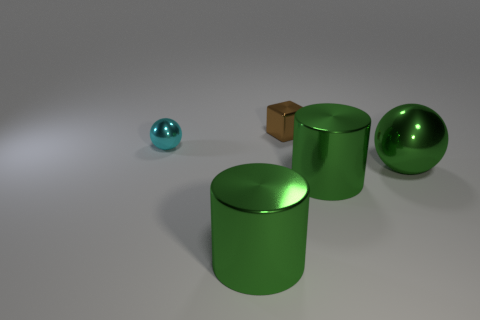Are there any other things that have the same shape as the brown metallic thing?
Provide a succinct answer. No. There is another big object that is the same shape as the cyan thing; what is its color?
Provide a short and direct response. Green. What number of tiny spheres have the same color as the big metallic ball?
Ensure brevity in your answer.  0. Is the big ball the same color as the small shiny sphere?
Your answer should be compact. No. What number of objects are metallic things that are to the right of the brown thing or green cylinders?
Provide a succinct answer. 3. What color is the big cylinder that is right of the metallic object that is behind the metal ball that is behind the green metallic sphere?
Keep it short and to the point. Green. There is another small thing that is the same material as the small brown object; what is its color?
Your answer should be compact. Cyan. How many other tiny things have the same material as the brown thing?
Give a very brief answer. 1. There is a ball in front of the cyan sphere; is its size the same as the block?
Offer a very short reply. No. There is a ball that is the same size as the metallic block; what color is it?
Keep it short and to the point. Cyan. 